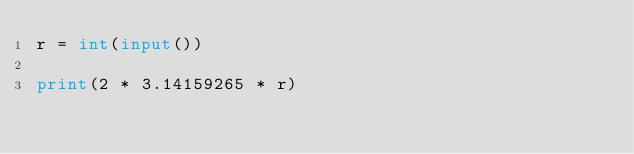Convert code to text. <code><loc_0><loc_0><loc_500><loc_500><_Python_>r = int(input())

print(2 * 3.14159265 * r)
</code> 